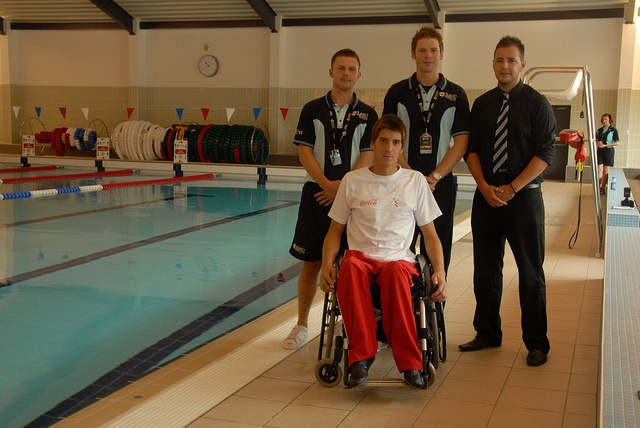Describe the objects in this image and their specific colors. I can see people in olive, black, maroon, and brown tones, people in olive, maroon, tan, and gray tones, people in olive, black, maroon, and brown tones, people in olive, black, gray, maroon, and brown tones, and people in olive, black, maroon, and tan tones in this image. 